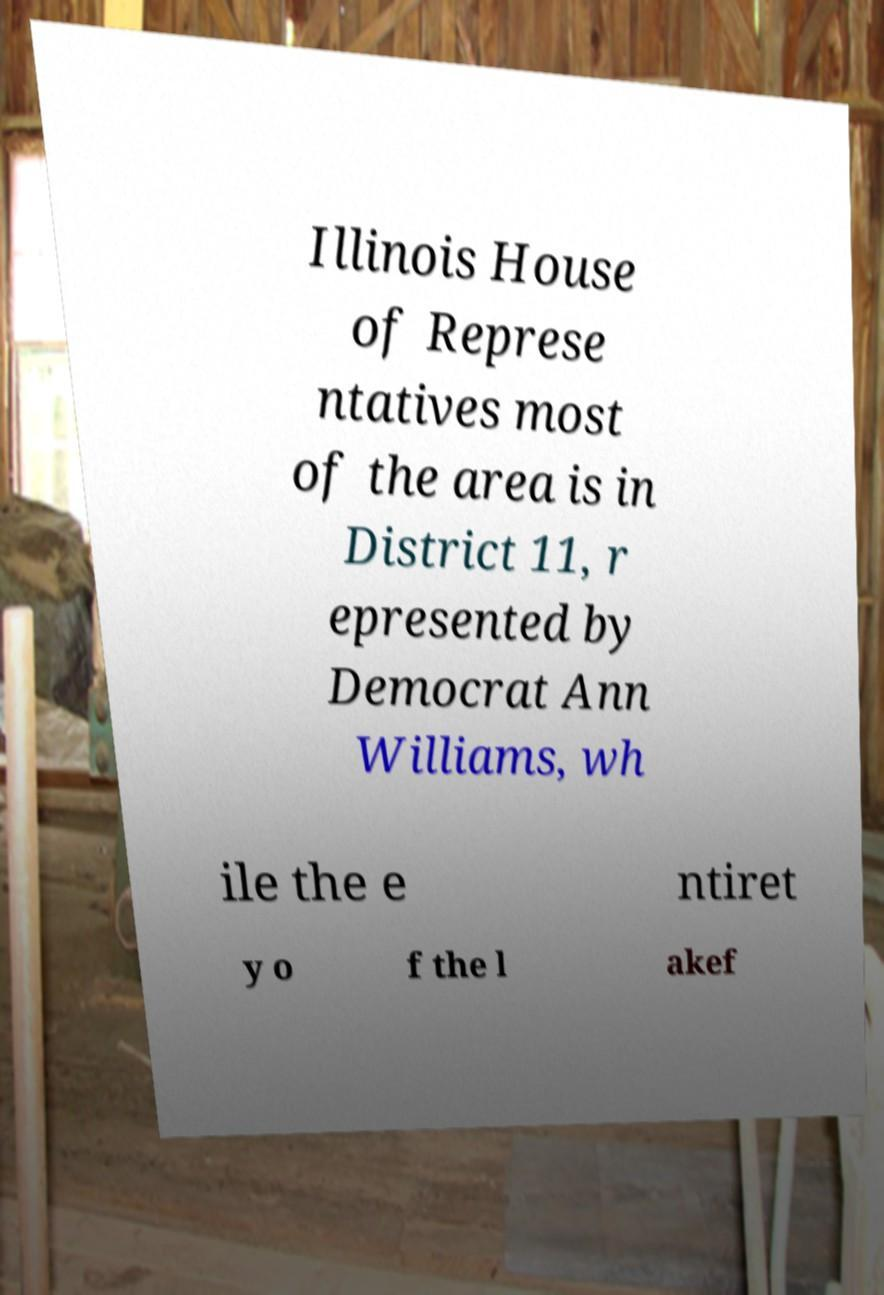Can you accurately transcribe the text from the provided image for me? Illinois House of Represe ntatives most of the area is in District 11, r epresented by Democrat Ann Williams, wh ile the e ntiret y o f the l akef 